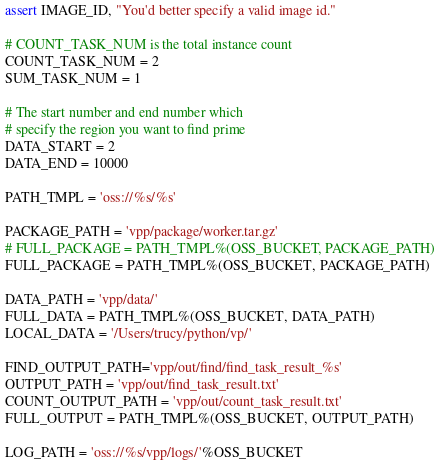<code> <loc_0><loc_0><loc_500><loc_500><_Python_>assert IMAGE_ID, "You'd better specify a valid image id."

# COUNT_TASK_NUM is the total instance count
COUNT_TASK_NUM = 2
SUM_TASK_NUM = 1

# The start number and end number which
# specify the region you want to find prime
DATA_START = 2
DATA_END = 10000

PATH_TMPL = 'oss://%s/%s'

PACKAGE_PATH = 'vpp/package/worker.tar.gz'
# FULL_PACKAGE = PATH_TMPL%(OSS_BUCKET, PACKAGE_PATH)
FULL_PACKAGE = PATH_TMPL%(OSS_BUCKET, PACKAGE_PATH)

DATA_PATH = 'vpp/data/'
FULL_DATA = PATH_TMPL%(OSS_BUCKET, DATA_PATH)
LOCAL_DATA = '/Users/trucy/python/vp/'

FIND_OUTPUT_PATH='vpp/out/find/find_task_result_%s'
OUTPUT_PATH = 'vpp/out/find_task_result.txt'
COUNT_OUTPUT_PATH = 'vpp/out/count_task_result.txt'
FULL_OUTPUT = PATH_TMPL%(OSS_BUCKET, OUTPUT_PATH)

LOG_PATH = 'oss://%s/vpp/logs/'%OSS_BUCKET


</code> 